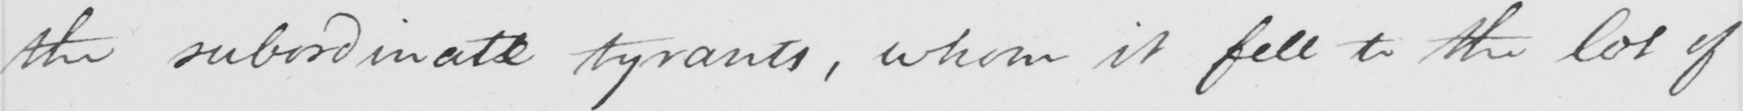Can you tell me what this handwritten text says? the subordinate tyrants , whom it fell to the lot of 